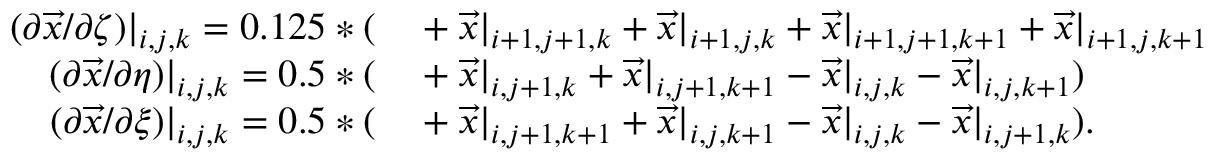Convert formula to latex. <formula><loc_0><loc_0><loc_500><loc_500>\begin{array} { r l } { ( \partial \overrightarrow { x } / \partial \zeta ) | _ { i , j , k } = 0 . 1 2 5 * ( } & + \overrightarrow { x } | _ { i + 1 , j + 1 , k } + \overrightarrow { x } | _ { i + 1 , j , k } + \overrightarrow { x } | _ { i + 1 , j + 1 , k + 1 } + \overrightarrow { x } | _ { i + 1 , j , k + 1 } } \\ { ( \partial \overrightarrow { x } / \partial \eta ) | _ { i , j , k } = 0 . 5 * ( } & + \overrightarrow { x } | _ { i , j + 1 , k } + \overrightarrow { x } | _ { i , j + 1 , k + 1 } - \overrightarrow { x } | _ { i , j , k } - \overrightarrow { x } | _ { i , j , k + 1 } ) } \\ { ( \partial \overrightarrow { x } / \partial \xi ) | _ { i , j , k } = 0 . 5 * ( } & + \overrightarrow { x } | _ { i , j + 1 , k + 1 } + \overrightarrow { x } | _ { i , j , k + 1 } - \overrightarrow { x } | _ { i , j , k } - \overrightarrow { x } | _ { i , j + 1 , k } ) . } \end{array}</formula> 